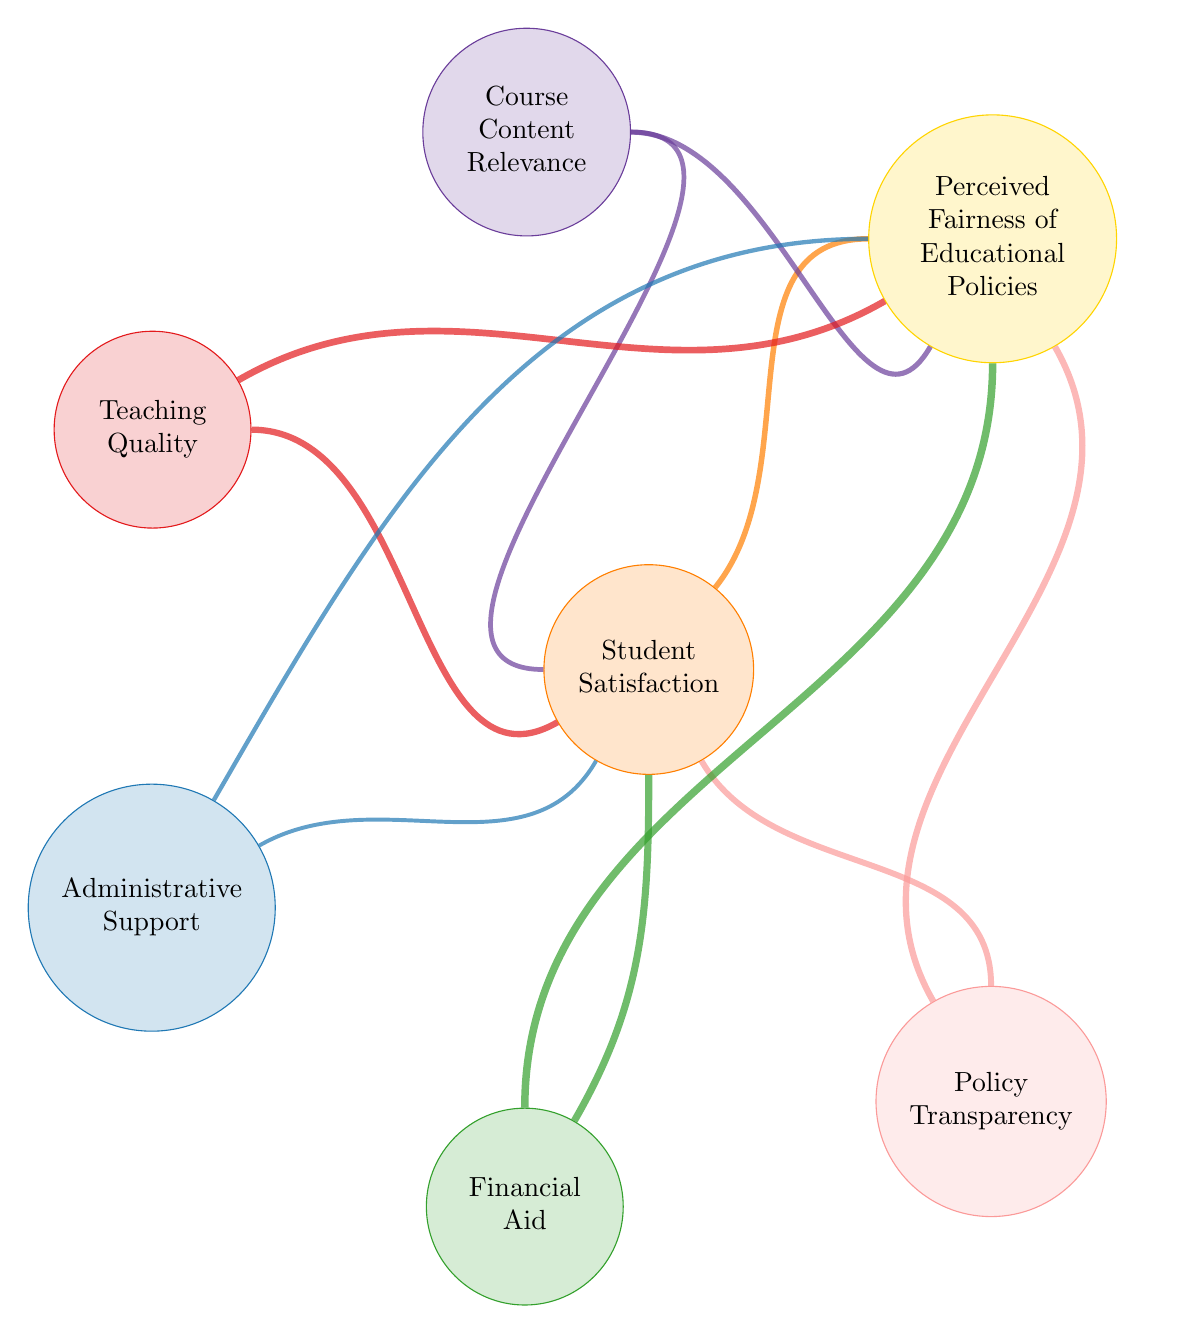What is the link value between Student Satisfaction and Perceived Fairness of Educational Policies? The diagram shows a direct link between "Student Satisfaction" and "Perceived Fairness of Educational Policies," with a value labeled as 70.
Answer: 70 What node has the highest influence on Student Satisfaction? The diagram indicates that the "Financial Aid" node has the highest link value to "Student Satisfaction," which is 90.
Answer: Financial Aid How many nodes are connected to Student Satisfaction? By examining the diagram, I can count that there are six nodes connected to "Student Satisfaction" through various links.
Answer: 6 Which node has the connection with the lowest value to Perceived Fairness of Educational Policies? Reviewing the connections to "Perceived Fairness of Educational Policies," I see the link from "Administrative Support" has the lowest value, which is 55.
Answer: Administrative Support What is the sum of the values of connections from Financial Aid to both Student Satisfaction and Perceived Fairness of Educational Policies? The value from "Financial Aid" to "Student Satisfaction" is 90, and to "Perceived Fairness of Educational Policies," it is 95. Adding these together gives 90 + 95 = 185.
Answer: 185 Which two factors have the highest influence on Perceived Fairness of Educational Policies? In the diagram, the two factors with the highest connection values to "Perceived Fairness of Educational Policies" are "Financial Aid" (95) and "Teaching Quality" (85).
Answer: Financial Aid and Teaching Quality What percentage of the link value from Teaching Quality to Student Satisfaction contributes to the total link values from Teaching Quality? There is a total of two links from "Teaching Quality": to "Student Satisfaction" (80) and to "Perceived Fairness of Educational Policies" (85), totaling 165. The contribution to "Student Satisfaction" alone is 80, which is about 48.5% when calculated.
Answer: 48.5% What is the relationship between Course Content Relevance and Perceived Fairness of Educational Policies? The diagram shows a direct link from "Course Content Relevance" to "Perceived Fairness of Educational Policies" with a value labeled as 65, indicating a positive relationship.
Answer: 65 How does the connection of Policy Transparency to Student Satisfaction compare to its connection to Perceived Fairness of Educational Policies? The link from "Policy Transparency" to "Student Satisfaction" is valued at 75, and to "Perceived Fairness of Educational Policies," it is valued at 80, indicating that the latter is stronger by 5.
Answer: 5 (stronger to Perceived Fairness) 